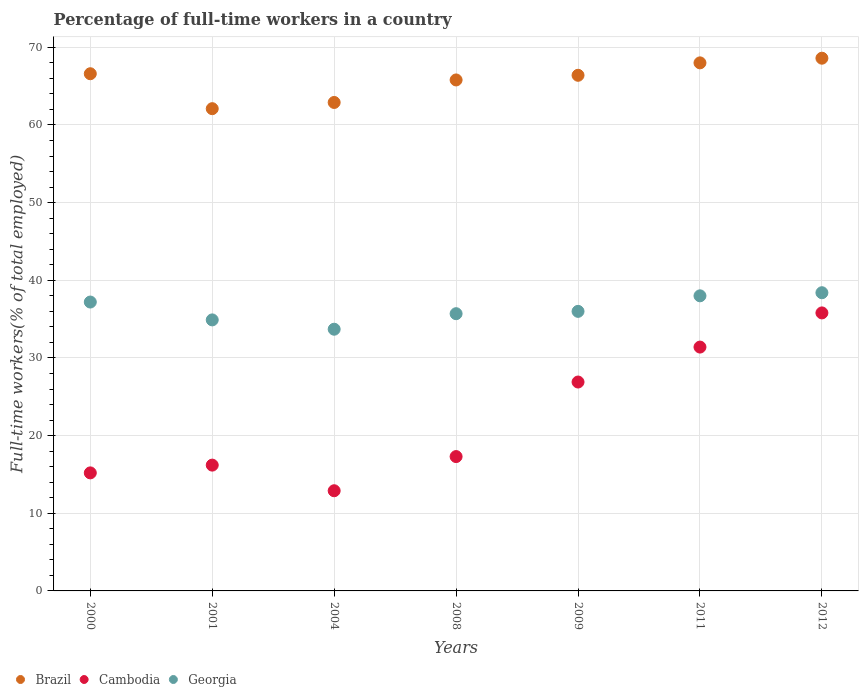How many different coloured dotlines are there?
Offer a very short reply. 3. What is the percentage of full-time workers in Brazil in 2011?
Offer a very short reply. 68. Across all years, what is the maximum percentage of full-time workers in Brazil?
Offer a very short reply. 68.6. Across all years, what is the minimum percentage of full-time workers in Georgia?
Provide a succinct answer. 33.7. In which year was the percentage of full-time workers in Cambodia maximum?
Ensure brevity in your answer.  2012. In which year was the percentage of full-time workers in Georgia minimum?
Ensure brevity in your answer.  2004. What is the total percentage of full-time workers in Georgia in the graph?
Your response must be concise. 253.9. What is the difference between the percentage of full-time workers in Brazil in 2011 and that in 2012?
Your response must be concise. -0.6. What is the difference between the percentage of full-time workers in Cambodia in 2011 and the percentage of full-time workers in Georgia in 2012?
Offer a terse response. -7. What is the average percentage of full-time workers in Brazil per year?
Provide a short and direct response. 65.77. In the year 2008, what is the difference between the percentage of full-time workers in Georgia and percentage of full-time workers in Cambodia?
Give a very brief answer. 18.4. In how many years, is the percentage of full-time workers in Brazil greater than 18 %?
Your answer should be compact. 7. What is the ratio of the percentage of full-time workers in Brazil in 2000 to that in 2011?
Provide a succinct answer. 0.98. Is the difference between the percentage of full-time workers in Georgia in 2000 and 2011 greater than the difference between the percentage of full-time workers in Cambodia in 2000 and 2011?
Offer a very short reply. Yes. What is the difference between the highest and the second highest percentage of full-time workers in Cambodia?
Make the answer very short. 4.4. What is the difference between the highest and the lowest percentage of full-time workers in Georgia?
Make the answer very short. 4.7. In how many years, is the percentage of full-time workers in Georgia greater than the average percentage of full-time workers in Georgia taken over all years?
Offer a very short reply. 3. Is it the case that in every year, the sum of the percentage of full-time workers in Cambodia and percentage of full-time workers in Georgia  is greater than the percentage of full-time workers in Brazil?
Make the answer very short. No. Does the percentage of full-time workers in Georgia monotonically increase over the years?
Make the answer very short. No. What is the difference between two consecutive major ticks on the Y-axis?
Provide a succinct answer. 10. Does the graph contain any zero values?
Ensure brevity in your answer.  No. Does the graph contain grids?
Offer a terse response. Yes. Where does the legend appear in the graph?
Provide a short and direct response. Bottom left. How are the legend labels stacked?
Ensure brevity in your answer.  Horizontal. What is the title of the graph?
Give a very brief answer. Percentage of full-time workers in a country. Does "Kiribati" appear as one of the legend labels in the graph?
Offer a terse response. No. What is the label or title of the X-axis?
Make the answer very short. Years. What is the label or title of the Y-axis?
Offer a very short reply. Full-time workers(% of total employed). What is the Full-time workers(% of total employed) of Brazil in 2000?
Ensure brevity in your answer.  66.6. What is the Full-time workers(% of total employed) of Cambodia in 2000?
Provide a short and direct response. 15.2. What is the Full-time workers(% of total employed) in Georgia in 2000?
Provide a short and direct response. 37.2. What is the Full-time workers(% of total employed) of Brazil in 2001?
Give a very brief answer. 62.1. What is the Full-time workers(% of total employed) of Cambodia in 2001?
Ensure brevity in your answer.  16.2. What is the Full-time workers(% of total employed) of Georgia in 2001?
Provide a succinct answer. 34.9. What is the Full-time workers(% of total employed) of Brazil in 2004?
Your response must be concise. 62.9. What is the Full-time workers(% of total employed) of Cambodia in 2004?
Ensure brevity in your answer.  12.9. What is the Full-time workers(% of total employed) in Georgia in 2004?
Keep it short and to the point. 33.7. What is the Full-time workers(% of total employed) in Brazil in 2008?
Provide a short and direct response. 65.8. What is the Full-time workers(% of total employed) in Cambodia in 2008?
Keep it short and to the point. 17.3. What is the Full-time workers(% of total employed) in Georgia in 2008?
Offer a terse response. 35.7. What is the Full-time workers(% of total employed) in Brazil in 2009?
Give a very brief answer. 66.4. What is the Full-time workers(% of total employed) in Cambodia in 2009?
Your response must be concise. 26.9. What is the Full-time workers(% of total employed) of Georgia in 2009?
Give a very brief answer. 36. What is the Full-time workers(% of total employed) of Cambodia in 2011?
Your response must be concise. 31.4. What is the Full-time workers(% of total employed) in Georgia in 2011?
Ensure brevity in your answer.  38. What is the Full-time workers(% of total employed) in Brazil in 2012?
Keep it short and to the point. 68.6. What is the Full-time workers(% of total employed) of Cambodia in 2012?
Your answer should be very brief. 35.8. What is the Full-time workers(% of total employed) of Georgia in 2012?
Offer a terse response. 38.4. Across all years, what is the maximum Full-time workers(% of total employed) in Brazil?
Provide a short and direct response. 68.6. Across all years, what is the maximum Full-time workers(% of total employed) of Cambodia?
Your answer should be compact. 35.8. Across all years, what is the maximum Full-time workers(% of total employed) in Georgia?
Your answer should be very brief. 38.4. Across all years, what is the minimum Full-time workers(% of total employed) of Brazil?
Your answer should be compact. 62.1. Across all years, what is the minimum Full-time workers(% of total employed) in Cambodia?
Offer a very short reply. 12.9. Across all years, what is the minimum Full-time workers(% of total employed) of Georgia?
Keep it short and to the point. 33.7. What is the total Full-time workers(% of total employed) in Brazil in the graph?
Provide a succinct answer. 460.4. What is the total Full-time workers(% of total employed) in Cambodia in the graph?
Offer a very short reply. 155.7. What is the total Full-time workers(% of total employed) in Georgia in the graph?
Make the answer very short. 253.9. What is the difference between the Full-time workers(% of total employed) of Brazil in 2000 and that in 2004?
Provide a succinct answer. 3.7. What is the difference between the Full-time workers(% of total employed) of Georgia in 2000 and that in 2004?
Provide a succinct answer. 3.5. What is the difference between the Full-time workers(% of total employed) of Cambodia in 2000 and that in 2008?
Offer a terse response. -2.1. What is the difference between the Full-time workers(% of total employed) of Brazil in 2000 and that in 2009?
Your answer should be very brief. 0.2. What is the difference between the Full-time workers(% of total employed) of Cambodia in 2000 and that in 2011?
Your answer should be very brief. -16.2. What is the difference between the Full-time workers(% of total employed) in Georgia in 2000 and that in 2011?
Your answer should be compact. -0.8. What is the difference between the Full-time workers(% of total employed) of Brazil in 2000 and that in 2012?
Ensure brevity in your answer.  -2. What is the difference between the Full-time workers(% of total employed) of Cambodia in 2000 and that in 2012?
Your answer should be very brief. -20.6. What is the difference between the Full-time workers(% of total employed) of Cambodia in 2001 and that in 2004?
Offer a very short reply. 3.3. What is the difference between the Full-time workers(% of total employed) of Brazil in 2001 and that in 2008?
Ensure brevity in your answer.  -3.7. What is the difference between the Full-time workers(% of total employed) of Cambodia in 2001 and that in 2008?
Your answer should be compact. -1.1. What is the difference between the Full-time workers(% of total employed) in Brazil in 2001 and that in 2009?
Provide a succinct answer. -4.3. What is the difference between the Full-time workers(% of total employed) in Cambodia in 2001 and that in 2009?
Provide a succinct answer. -10.7. What is the difference between the Full-time workers(% of total employed) in Brazil in 2001 and that in 2011?
Ensure brevity in your answer.  -5.9. What is the difference between the Full-time workers(% of total employed) in Cambodia in 2001 and that in 2011?
Keep it short and to the point. -15.2. What is the difference between the Full-time workers(% of total employed) in Brazil in 2001 and that in 2012?
Keep it short and to the point. -6.5. What is the difference between the Full-time workers(% of total employed) in Cambodia in 2001 and that in 2012?
Provide a succinct answer. -19.6. What is the difference between the Full-time workers(% of total employed) in Cambodia in 2004 and that in 2008?
Ensure brevity in your answer.  -4.4. What is the difference between the Full-time workers(% of total employed) in Cambodia in 2004 and that in 2009?
Keep it short and to the point. -14. What is the difference between the Full-time workers(% of total employed) in Georgia in 2004 and that in 2009?
Offer a very short reply. -2.3. What is the difference between the Full-time workers(% of total employed) in Brazil in 2004 and that in 2011?
Ensure brevity in your answer.  -5.1. What is the difference between the Full-time workers(% of total employed) of Cambodia in 2004 and that in 2011?
Make the answer very short. -18.5. What is the difference between the Full-time workers(% of total employed) in Georgia in 2004 and that in 2011?
Give a very brief answer. -4.3. What is the difference between the Full-time workers(% of total employed) of Cambodia in 2004 and that in 2012?
Make the answer very short. -22.9. What is the difference between the Full-time workers(% of total employed) of Georgia in 2004 and that in 2012?
Offer a very short reply. -4.7. What is the difference between the Full-time workers(% of total employed) in Cambodia in 2008 and that in 2009?
Your answer should be compact. -9.6. What is the difference between the Full-time workers(% of total employed) in Georgia in 2008 and that in 2009?
Ensure brevity in your answer.  -0.3. What is the difference between the Full-time workers(% of total employed) of Cambodia in 2008 and that in 2011?
Provide a succinct answer. -14.1. What is the difference between the Full-time workers(% of total employed) of Cambodia in 2008 and that in 2012?
Make the answer very short. -18.5. What is the difference between the Full-time workers(% of total employed) of Brazil in 2009 and that in 2011?
Ensure brevity in your answer.  -1.6. What is the difference between the Full-time workers(% of total employed) in Cambodia in 2009 and that in 2012?
Ensure brevity in your answer.  -8.9. What is the difference between the Full-time workers(% of total employed) in Georgia in 2009 and that in 2012?
Your response must be concise. -2.4. What is the difference between the Full-time workers(% of total employed) of Cambodia in 2011 and that in 2012?
Your response must be concise. -4.4. What is the difference between the Full-time workers(% of total employed) in Brazil in 2000 and the Full-time workers(% of total employed) in Cambodia in 2001?
Keep it short and to the point. 50.4. What is the difference between the Full-time workers(% of total employed) of Brazil in 2000 and the Full-time workers(% of total employed) of Georgia in 2001?
Your answer should be compact. 31.7. What is the difference between the Full-time workers(% of total employed) of Cambodia in 2000 and the Full-time workers(% of total employed) of Georgia in 2001?
Make the answer very short. -19.7. What is the difference between the Full-time workers(% of total employed) in Brazil in 2000 and the Full-time workers(% of total employed) in Cambodia in 2004?
Ensure brevity in your answer.  53.7. What is the difference between the Full-time workers(% of total employed) of Brazil in 2000 and the Full-time workers(% of total employed) of Georgia in 2004?
Keep it short and to the point. 32.9. What is the difference between the Full-time workers(% of total employed) of Cambodia in 2000 and the Full-time workers(% of total employed) of Georgia in 2004?
Keep it short and to the point. -18.5. What is the difference between the Full-time workers(% of total employed) in Brazil in 2000 and the Full-time workers(% of total employed) in Cambodia in 2008?
Offer a terse response. 49.3. What is the difference between the Full-time workers(% of total employed) in Brazil in 2000 and the Full-time workers(% of total employed) in Georgia in 2008?
Offer a very short reply. 30.9. What is the difference between the Full-time workers(% of total employed) in Cambodia in 2000 and the Full-time workers(% of total employed) in Georgia in 2008?
Your answer should be very brief. -20.5. What is the difference between the Full-time workers(% of total employed) in Brazil in 2000 and the Full-time workers(% of total employed) in Cambodia in 2009?
Make the answer very short. 39.7. What is the difference between the Full-time workers(% of total employed) in Brazil in 2000 and the Full-time workers(% of total employed) in Georgia in 2009?
Your answer should be compact. 30.6. What is the difference between the Full-time workers(% of total employed) in Cambodia in 2000 and the Full-time workers(% of total employed) in Georgia in 2009?
Offer a terse response. -20.8. What is the difference between the Full-time workers(% of total employed) of Brazil in 2000 and the Full-time workers(% of total employed) of Cambodia in 2011?
Your response must be concise. 35.2. What is the difference between the Full-time workers(% of total employed) of Brazil in 2000 and the Full-time workers(% of total employed) of Georgia in 2011?
Ensure brevity in your answer.  28.6. What is the difference between the Full-time workers(% of total employed) of Cambodia in 2000 and the Full-time workers(% of total employed) of Georgia in 2011?
Provide a succinct answer. -22.8. What is the difference between the Full-time workers(% of total employed) in Brazil in 2000 and the Full-time workers(% of total employed) in Cambodia in 2012?
Give a very brief answer. 30.8. What is the difference between the Full-time workers(% of total employed) of Brazil in 2000 and the Full-time workers(% of total employed) of Georgia in 2012?
Offer a terse response. 28.2. What is the difference between the Full-time workers(% of total employed) of Cambodia in 2000 and the Full-time workers(% of total employed) of Georgia in 2012?
Keep it short and to the point. -23.2. What is the difference between the Full-time workers(% of total employed) of Brazil in 2001 and the Full-time workers(% of total employed) of Cambodia in 2004?
Your response must be concise. 49.2. What is the difference between the Full-time workers(% of total employed) in Brazil in 2001 and the Full-time workers(% of total employed) in Georgia in 2004?
Give a very brief answer. 28.4. What is the difference between the Full-time workers(% of total employed) in Cambodia in 2001 and the Full-time workers(% of total employed) in Georgia in 2004?
Offer a very short reply. -17.5. What is the difference between the Full-time workers(% of total employed) of Brazil in 2001 and the Full-time workers(% of total employed) of Cambodia in 2008?
Your response must be concise. 44.8. What is the difference between the Full-time workers(% of total employed) in Brazil in 2001 and the Full-time workers(% of total employed) in Georgia in 2008?
Ensure brevity in your answer.  26.4. What is the difference between the Full-time workers(% of total employed) of Cambodia in 2001 and the Full-time workers(% of total employed) of Georgia in 2008?
Your answer should be compact. -19.5. What is the difference between the Full-time workers(% of total employed) in Brazil in 2001 and the Full-time workers(% of total employed) in Cambodia in 2009?
Ensure brevity in your answer.  35.2. What is the difference between the Full-time workers(% of total employed) in Brazil in 2001 and the Full-time workers(% of total employed) in Georgia in 2009?
Provide a succinct answer. 26.1. What is the difference between the Full-time workers(% of total employed) in Cambodia in 2001 and the Full-time workers(% of total employed) in Georgia in 2009?
Your answer should be very brief. -19.8. What is the difference between the Full-time workers(% of total employed) in Brazil in 2001 and the Full-time workers(% of total employed) in Cambodia in 2011?
Provide a short and direct response. 30.7. What is the difference between the Full-time workers(% of total employed) of Brazil in 2001 and the Full-time workers(% of total employed) of Georgia in 2011?
Your answer should be very brief. 24.1. What is the difference between the Full-time workers(% of total employed) of Cambodia in 2001 and the Full-time workers(% of total employed) of Georgia in 2011?
Offer a very short reply. -21.8. What is the difference between the Full-time workers(% of total employed) in Brazil in 2001 and the Full-time workers(% of total employed) in Cambodia in 2012?
Your response must be concise. 26.3. What is the difference between the Full-time workers(% of total employed) in Brazil in 2001 and the Full-time workers(% of total employed) in Georgia in 2012?
Provide a short and direct response. 23.7. What is the difference between the Full-time workers(% of total employed) of Cambodia in 2001 and the Full-time workers(% of total employed) of Georgia in 2012?
Offer a very short reply. -22.2. What is the difference between the Full-time workers(% of total employed) in Brazil in 2004 and the Full-time workers(% of total employed) in Cambodia in 2008?
Your answer should be compact. 45.6. What is the difference between the Full-time workers(% of total employed) of Brazil in 2004 and the Full-time workers(% of total employed) of Georgia in 2008?
Offer a terse response. 27.2. What is the difference between the Full-time workers(% of total employed) of Cambodia in 2004 and the Full-time workers(% of total employed) of Georgia in 2008?
Your answer should be very brief. -22.8. What is the difference between the Full-time workers(% of total employed) of Brazil in 2004 and the Full-time workers(% of total employed) of Georgia in 2009?
Your answer should be very brief. 26.9. What is the difference between the Full-time workers(% of total employed) of Cambodia in 2004 and the Full-time workers(% of total employed) of Georgia in 2009?
Provide a short and direct response. -23.1. What is the difference between the Full-time workers(% of total employed) of Brazil in 2004 and the Full-time workers(% of total employed) of Cambodia in 2011?
Give a very brief answer. 31.5. What is the difference between the Full-time workers(% of total employed) of Brazil in 2004 and the Full-time workers(% of total employed) of Georgia in 2011?
Offer a terse response. 24.9. What is the difference between the Full-time workers(% of total employed) in Cambodia in 2004 and the Full-time workers(% of total employed) in Georgia in 2011?
Offer a terse response. -25.1. What is the difference between the Full-time workers(% of total employed) of Brazil in 2004 and the Full-time workers(% of total employed) of Cambodia in 2012?
Provide a short and direct response. 27.1. What is the difference between the Full-time workers(% of total employed) in Cambodia in 2004 and the Full-time workers(% of total employed) in Georgia in 2012?
Offer a very short reply. -25.5. What is the difference between the Full-time workers(% of total employed) of Brazil in 2008 and the Full-time workers(% of total employed) of Cambodia in 2009?
Ensure brevity in your answer.  38.9. What is the difference between the Full-time workers(% of total employed) of Brazil in 2008 and the Full-time workers(% of total employed) of Georgia in 2009?
Offer a very short reply. 29.8. What is the difference between the Full-time workers(% of total employed) of Cambodia in 2008 and the Full-time workers(% of total employed) of Georgia in 2009?
Keep it short and to the point. -18.7. What is the difference between the Full-time workers(% of total employed) of Brazil in 2008 and the Full-time workers(% of total employed) of Cambodia in 2011?
Your response must be concise. 34.4. What is the difference between the Full-time workers(% of total employed) in Brazil in 2008 and the Full-time workers(% of total employed) in Georgia in 2011?
Make the answer very short. 27.8. What is the difference between the Full-time workers(% of total employed) in Cambodia in 2008 and the Full-time workers(% of total employed) in Georgia in 2011?
Make the answer very short. -20.7. What is the difference between the Full-time workers(% of total employed) in Brazil in 2008 and the Full-time workers(% of total employed) in Cambodia in 2012?
Ensure brevity in your answer.  30. What is the difference between the Full-time workers(% of total employed) in Brazil in 2008 and the Full-time workers(% of total employed) in Georgia in 2012?
Offer a terse response. 27.4. What is the difference between the Full-time workers(% of total employed) in Cambodia in 2008 and the Full-time workers(% of total employed) in Georgia in 2012?
Offer a terse response. -21.1. What is the difference between the Full-time workers(% of total employed) of Brazil in 2009 and the Full-time workers(% of total employed) of Cambodia in 2011?
Your answer should be very brief. 35. What is the difference between the Full-time workers(% of total employed) of Brazil in 2009 and the Full-time workers(% of total employed) of Georgia in 2011?
Make the answer very short. 28.4. What is the difference between the Full-time workers(% of total employed) of Cambodia in 2009 and the Full-time workers(% of total employed) of Georgia in 2011?
Offer a terse response. -11.1. What is the difference between the Full-time workers(% of total employed) in Brazil in 2009 and the Full-time workers(% of total employed) in Cambodia in 2012?
Offer a terse response. 30.6. What is the difference between the Full-time workers(% of total employed) of Brazil in 2009 and the Full-time workers(% of total employed) of Georgia in 2012?
Keep it short and to the point. 28. What is the difference between the Full-time workers(% of total employed) in Brazil in 2011 and the Full-time workers(% of total employed) in Cambodia in 2012?
Give a very brief answer. 32.2. What is the difference between the Full-time workers(% of total employed) of Brazil in 2011 and the Full-time workers(% of total employed) of Georgia in 2012?
Ensure brevity in your answer.  29.6. What is the average Full-time workers(% of total employed) in Brazil per year?
Your answer should be compact. 65.77. What is the average Full-time workers(% of total employed) in Cambodia per year?
Your response must be concise. 22.24. What is the average Full-time workers(% of total employed) of Georgia per year?
Offer a terse response. 36.27. In the year 2000, what is the difference between the Full-time workers(% of total employed) of Brazil and Full-time workers(% of total employed) of Cambodia?
Ensure brevity in your answer.  51.4. In the year 2000, what is the difference between the Full-time workers(% of total employed) in Brazil and Full-time workers(% of total employed) in Georgia?
Offer a terse response. 29.4. In the year 2001, what is the difference between the Full-time workers(% of total employed) in Brazil and Full-time workers(% of total employed) in Cambodia?
Offer a terse response. 45.9. In the year 2001, what is the difference between the Full-time workers(% of total employed) in Brazil and Full-time workers(% of total employed) in Georgia?
Offer a very short reply. 27.2. In the year 2001, what is the difference between the Full-time workers(% of total employed) of Cambodia and Full-time workers(% of total employed) of Georgia?
Make the answer very short. -18.7. In the year 2004, what is the difference between the Full-time workers(% of total employed) of Brazil and Full-time workers(% of total employed) of Cambodia?
Make the answer very short. 50. In the year 2004, what is the difference between the Full-time workers(% of total employed) in Brazil and Full-time workers(% of total employed) in Georgia?
Offer a very short reply. 29.2. In the year 2004, what is the difference between the Full-time workers(% of total employed) of Cambodia and Full-time workers(% of total employed) of Georgia?
Provide a succinct answer. -20.8. In the year 2008, what is the difference between the Full-time workers(% of total employed) of Brazil and Full-time workers(% of total employed) of Cambodia?
Keep it short and to the point. 48.5. In the year 2008, what is the difference between the Full-time workers(% of total employed) in Brazil and Full-time workers(% of total employed) in Georgia?
Your answer should be very brief. 30.1. In the year 2008, what is the difference between the Full-time workers(% of total employed) in Cambodia and Full-time workers(% of total employed) in Georgia?
Provide a short and direct response. -18.4. In the year 2009, what is the difference between the Full-time workers(% of total employed) of Brazil and Full-time workers(% of total employed) of Cambodia?
Make the answer very short. 39.5. In the year 2009, what is the difference between the Full-time workers(% of total employed) in Brazil and Full-time workers(% of total employed) in Georgia?
Keep it short and to the point. 30.4. In the year 2009, what is the difference between the Full-time workers(% of total employed) of Cambodia and Full-time workers(% of total employed) of Georgia?
Offer a very short reply. -9.1. In the year 2011, what is the difference between the Full-time workers(% of total employed) in Brazil and Full-time workers(% of total employed) in Cambodia?
Provide a succinct answer. 36.6. In the year 2011, what is the difference between the Full-time workers(% of total employed) of Brazil and Full-time workers(% of total employed) of Georgia?
Keep it short and to the point. 30. In the year 2011, what is the difference between the Full-time workers(% of total employed) of Cambodia and Full-time workers(% of total employed) of Georgia?
Your answer should be compact. -6.6. In the year 2012, what is the difference between the Full-time workers(% of total employed) in Brazil and Full-time workers(% of total employed) in Cambodia?
Make the answer very short. 32.8. In the year 2012, what is the difference between the Full-time workers(% of total employed) of Brazil and Full-time workers(% of total employed) of Georgia?
Your answer should be compact. 30.2. In the year 2012, what is the difference between the Full-time workers(% of total employed) in Cambodia and Full-time workers(% of total employed) in Georgia?
Your answer should be compact. -2.6. What is the ratio of the Full-time workers(% of total employed) in Brazil in 2000 to that in 2001?
Offer a very short reply. 1.07. What is the ratio of the Full-time workers(% of total employed) of Cambodia in 2000 to that in 2001?
Provide a short and direct response. 0.94. What is the ratio of the Full-time workers(% of total employed) in Georgia in 2000 to that in 2001?
Give a very brief answer. 1.07. What is the ratio of the Full-time workers(% of total employed) of Brazil in 2000 to that in 2004?
Provide a short and direct response. 1.06. What is the ratio of the Full-time workers(% of total employed) in Cambodia in 2000 to that in 2004?
Offer a terse response. 1.18. What is the ratio of the Full-time workers(% of total employed) in Georgia in 2000 to that in 2004?
Make the answer very short. 1.1. What is the ratio of the Full-time workers(% of total employed) of Brazil in 2000 to that in 2008?
Give a very brief answer. 1.01. What is the ratio of the Full-time workers(% of total employed) of Cambodia in 2000 to that in 2008?
Your answer should be very brief. 0.88. What is the ratio of the Full-time workers(% of total employed) of Georgia in 2000 to that in 2008?
Offer a terse response. 1.04. What is the ratio of the Full-time workers(% of total employed) in Cambodia in 2000 to that in 2009?
Your answer should be compact. 0.57. What is the ratio of the Full-time workers(% of total employed) in Georgia in 2000 to that in 2009?
Your answer should be compact. 1.03. What is the ratio of the Full-time workers(% of total employed) of Brazil in 2000 to that in 2011?
Your answer should be compact. 0.98. What is the ratio of the Full-time workers(% of total employed) of Cambodia in 2000 to that in 2011?
Ensure brevity in your answer.  0.48. What is the ratio of the Full-time workers(% of total employed) of Georgia in 2000 to that in 2011?
Keep it short and to the point. 0.98. What is the ratio of the Full-time workers(% of total employed) of Brazil in 2000 to that in 2012?
Your response must be concise. 0.97. What is the ratio of the Full-time workers(% of total employed) in Cambodia in 2000 to that in 2012?
Keep it short and to the point. 0.42. What is the ratio of the Full-time workers(% of total employed) of Georgia in 2000 to that in 2012?
Provide a succinct answer. 0.97. What is the ratio of the Full-time workers(% of total employed) of Brazil in 2001 to that in 2004?
Your answer should be very brief. 0.99. What is the ratio of the Full-time workers(% of total employed) in Cambodia in 2001 to that in 2004?
Provide a short and direct response. 1.26. What is the ratio of the Full-time workers(% of total employed) of Georgia in 2001 to that in 2004?
Your answer should be very brief. 1.04. What is the ratio of the Full-time workers(% of total employed) of Brazil in 2001 to that in 2008?
Make the answer very short. 0.94. What is the ratio of the Full-time workers(% of total employed) in Cambodia in 2001 to that in 2008?
Give a very brief answer. 0.94. What is the ratio of the Full-time workers(% of total employed) of Georgia in 2001 to that in 2008?
Your response must be concise. 0.98. What is the ratio of the Full-time workers(% of total employed) of Brazil in 2001 to that in 2009?
Your answer should be compact. 0.94. What is the ratio of the Full-time workers(% of total employed) in Cambodia in 2001 to that in 2009?
Give a very brief answer. 0.6. What is the ratio of the Full-time workers(% of total employed) of Georgia in 2001 to that in 2009?
Your answer should be compact. 0.97. What is the ratio of the Full-time workers(% of total employed) of Brazil in 2001 to that in 2011?
Provide a short and direct response. 0.91. What is the ratio of the Full-time workers(% of total employed) of Cambodia in 2001 to that in 2011?
Offer a very short reply. 0.52. What is the ratio of the Full-time workers(% of total employed) of Georgia in 2001 to that in 2011?
Ensure brevity in your answer.  0.92. What is the ratio of the Full-time workers(% of total employed) in Brazil in 2001 to that in 2012?
Provide a short and direct response. 0.91. What is the ratio of the Full-time workers(% of total employed) of Cambodia in 2001 to that in 2012?
Your answer should be compact. 0.45. What is the ratio of the Full-time workers(% of total employed) of Georgia in 2001 to that in 2012?
Your answer should be compact. 0.91. What is the ratio of the Full-time workers(% of total employed) of Brazil in 2004 to that in 2008?
Your answer should be compact. 0.96. What is the ratio of the Full-time workers(% of total employed) of Cambodia in 2004 to that in 2008?
Make the answer very short. 0.75. What is the ratio of the Full-time workers(% of total employed) in Georgia in 2004 to that in 2008?
Provide a short and direct response. 0.94. What is the ratio of the Full-time workers(% of total employed) of Brazil in 2004 to that in 2009?
Offer a very short reply. 0.95. What is the ratio of the Full-time workers(% of total employed) in Cambodia in 2004 to that in 2009?
Offer a terse response. 0.48. What is the ratio of the Full-time workers(% of total employed) of Georgia in 2004 to that in 2009?
Provide a short and direct response. 0.94. What is the ratio of the Full-time workers(% of total employed) in Brazil in 2004 to that in 2011?
Offer a terse response. 0.93. What is the ratio of the Full-time workers(% of total employed) in Cambodia in 2004 to that in 2011?
Give a very brief answer. 0.41. What is the ratio of the Full-time workers(% of total employed) of Georgia in 2004 to that in 2011?
Give a very brief answer. 0.89. What is the ratio of the Full-time workers(% of total employed) of Brazil in 2004 to that in 2012?
Provide a succinct answer. 0.92. What is the ratio of the Full-time workers(% of total employed) in Cambodia in 2004 to that in 2012?
Your answer should be very brief. 0.36. What is the ratio of the Full-time workers(% of total employed) in Georgia in 2004 to that in 2012?
Keep it short and to the point. 0.88. What is the ratio of the Full-time workers(% of total employed) in Brazil in 2008 to that in 2009?
Give a very brief answer. 0.99. What is the ratio of the Full-time workers(% of total employed) of Cambodia in 2008 to that in 2009?
Make the answer very short. 0.64. What is the ratio of the Full-time workers(% of total employed) in Brazil in 2008 to that in 2011?
Your answer should be very brief. 0.97. What is the ratio of the Full-time workers(% of total employed) of Cambodia in 2008 to that in 2011?
Your answer should be very brief. 0.55. What is the ratio of the Full-time workers(% of total employed) in Georgia in 2008 to that in 2011?
Provide a short and direct response. 0.94. What is the ratio of the Full-time workers(% of total employed) in Brazil in 2008 to that in 2012?
Make the answer very short. 0.96. What is the ratio of the Full-time workers(% of total employed) in Cambodia in 2008 to that in 2012?
Give a very brief answer. 0.48. What is the ratio of the Full-time workers(% of total employed) of Georgia in 2008 to that in 2012?
Offer a very short reply. 0.93. What is the ratio of the Full-time workers(% of total employed) in Brazil in 2009 to that in 2011?
Offer a very short reply. 0.98. What is the ratio of the Full-time workers(% of total employed) in Cambodia in 2009 to that in 2011?
Keep it short and to the point. 0.86. What is the ratio of the Full-time workers(% of total employed) in Brazil in 2009 to that in 2012?
Provide a succinct answer. 0.97. What is the ratio of the Full-time workers(% of total employed) in Cambodia in 2009 to that in 2012?
Offer a terse response. 0.75. What is the ratio of the Full-time workers(% of total employed) of Cambodia in 2011 to that in 2012?
Offer a very short reply. 0.88. What is the ratio of the Full-time workers(% of total employed) of Georgia in 2011 to that in 2012?
Keep it short and to the point. 0.99. What is the difference between the highest and the second highest Full-time workers(% of total employed) in Georgia?
Give a very brief answer. 0.4. What is the difference between the highest and the lowest Full-time workers(% of total employed) in Cambodia?
Offer a very short reply. 22.9. 